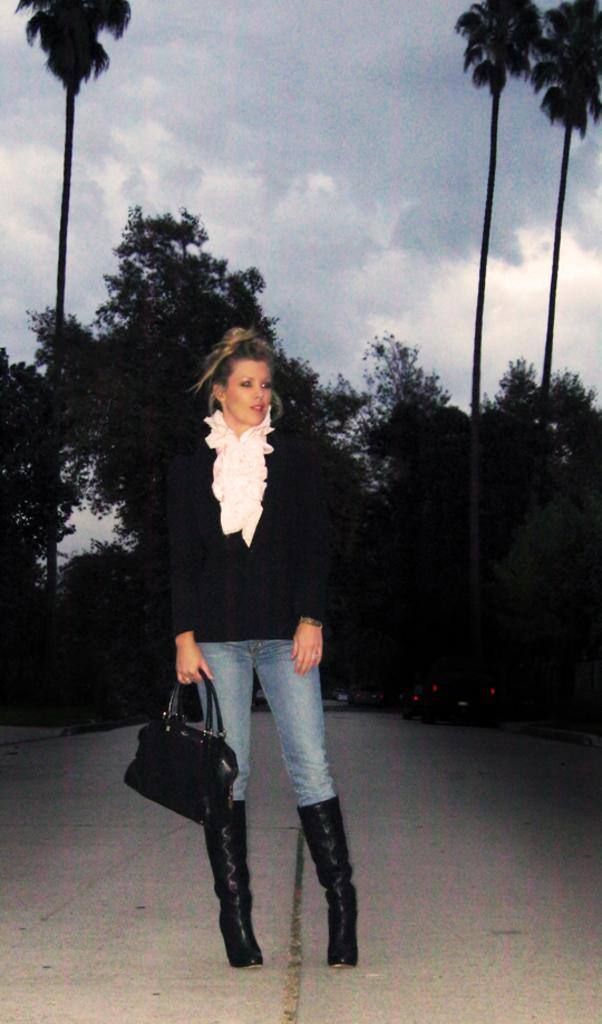What is the main subject of the image? The main subject of the image is a woman. What is the woman doing in the image? The woman is standing in the image. What accessory does the woman have in the image? The woman has a handbag in the image. What can be seen in the background of the image? Trees and the sky are visible in the background of the image. What type of slope can be seen in the image? There is no slope present in the image. How does the woman use the salt in the image? There is no salt present in the image. 